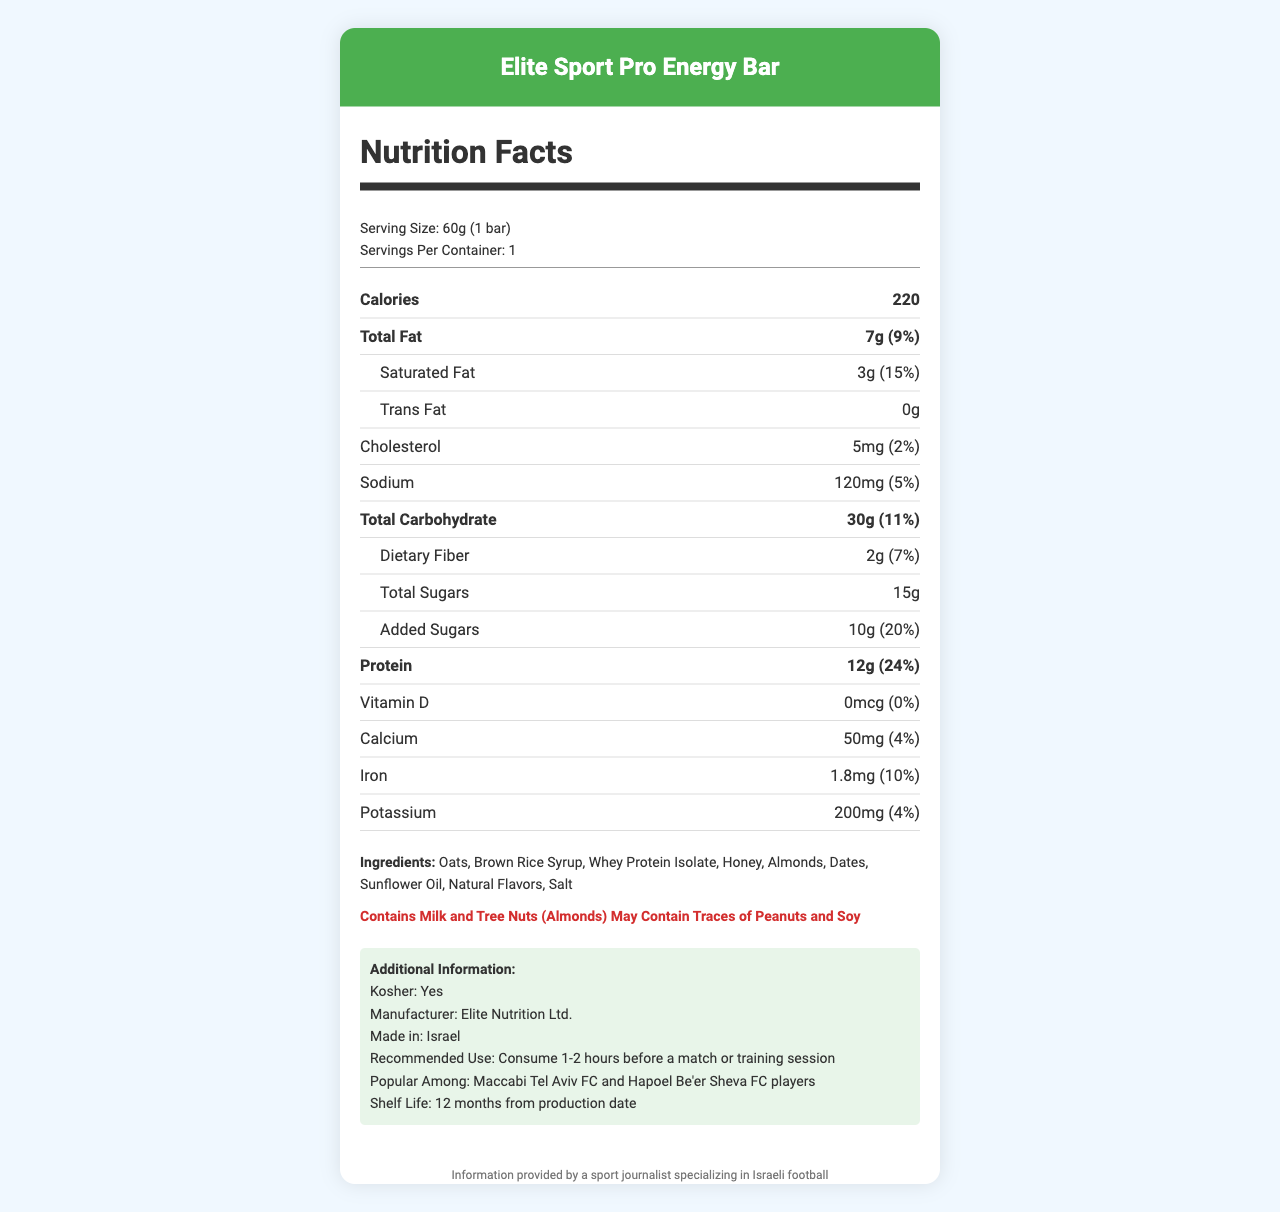who is the manufacturer of the Elite Sport Pro Energy Bar? The document states: "Manufacturer: Elite Nutrition Ltd."
Answer: Elite Nutrition Ltd. what is the serving size of the energy bar? The serving size is specified in the document as "Serving Size: 60g (1 bar)".
Answer: 60g (1 bar) how much protein does one bar have? The amount of protein in one serving is specified as "Protein: 12g (24% daily value)".
Answer: 12g which ingredients are potentially allergenic? The document lists "Contains Milk and Tree Nuts (Almonds)" under allergens.
Answer: Milk and Tree Nuts (Almonds) how many calories does one energy bar contain? The document states "Calories: 220".
Answer: 220 what percentage of the daily value does the total fat represent? Total fat is listed as "Total Fat: 7g (9% daily value)".
Answer: 9% True or False: The energy bar is kosher certified. The document includes the information "Kosher: Yes".
Answer: True what are the main ingredients of the energy bar? The document lists the ingredients as "Oats, Brown Rice Syrup, Whey Protein Isolate, Honey, Almonds, Dates, Sunflower Oil, Natural Flavors, Salt".
Answer: Oats, Brown Rice Syrup, Whey Protein Isolate, Honey, Almonds, Dates, Sunflower Oil, Natural Flavors, Salt describe the entire document. The document comprises various sections such as the product name, serving size, servings per container, nutritional content including calories, fats, carbohydrates, proteins, vitamins, and minerals. It lists the ingredients, allergens, and additional product information like kosher status, manufacturer, made in Israel, usage recommendation, popularity among players, and shelf life.
Answer: It provides detailed nutritional information for the Elite Sport Pro Energy Bar, including serving size, calories, macronutrients, vitamins, minerals, ingredients, allergens, and additional product information. What is a popular use recommendation for this energy bar? A. As a dessert B. Before a workout C. During a workout D. After a workout The document states the recommendation: "Consume 1-2 hours before a match or training session".
Answer: B How much iron does the energy bar provide? The amount of iron is listed as "Iron: 1.8mg (10% daily value)".
Answer: 1.8mg (10%) which football clubs' players are popular consumers of this energy bar? A. Maccabi Haifa FC and Beitar Jerusalem FC B. Hapoel Tel Aviv FC and Bnei Sakhnin FC C. Maccabi Tel Aviv FC and Hapoel Be'er Sheva FC The document states: "Popular Among: Maccabi Tel Aviv FC and Hapoel Be'er Sheva FC players".
Answer: C how much trans fat does the bar contain? The document lists "Trans Fat: 0g".
Answer: 0g how much-added sugar is in one bar, and what percentage of the daily value does it represent? The added sugars are listed as "Added Sugars: 10g (20% daily value)".
Answer: 10g (20%) What is the shelf life of the energy bar from the production date? The additional information section states "Shelf Life: 12 months from production date".
Answer: 12 months Can the specific production date of this energy bar be determined from the document? The document provides the shelf life but does not specify the exact production date.
Answer: Not enough information 